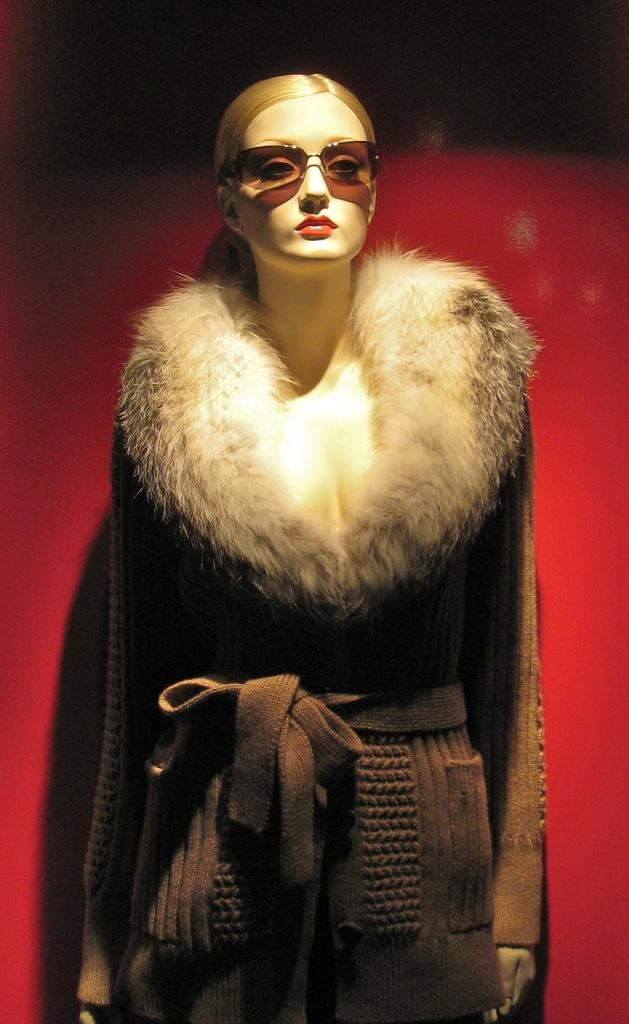What is the main subject of the image? There is a woman standing in the image. What is the woman wearing? The woman is wearing a coat. What can be seen in the background of the image? There is a wall in the background of the image. What color is the wall? The wall is painted red. What type of rod is being used by the woman to provide comfort in the image? There is no rod or indication of comfort being provided in the image. 